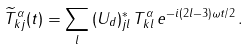<formula> <loc_0><loc_0><loc_500><loc_500>\widetilde { T } ^ { \alpha } _ { k j } ( t ) = \sum _ { l } { ( U _ { d } ) } ^ { * } _ { j l } \, T ^ { \alpha } _ { k l } \, e ^ { - i ( 2 l - 3 ) \omega t / 2 } \, .</formula> 